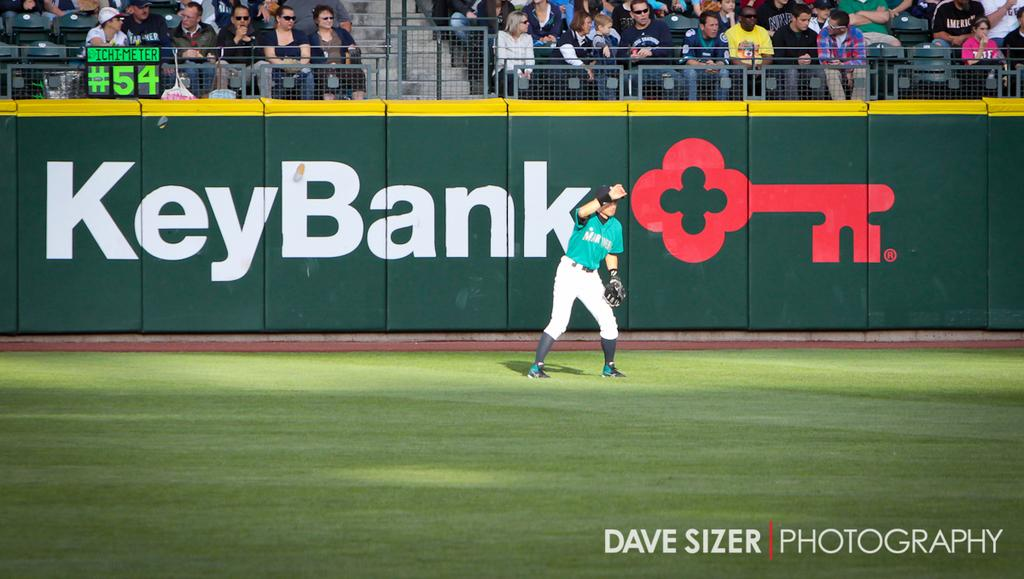<image>
Render a clear and concise summary of the photo. a baseball stadium and fence with keybank on the fence 